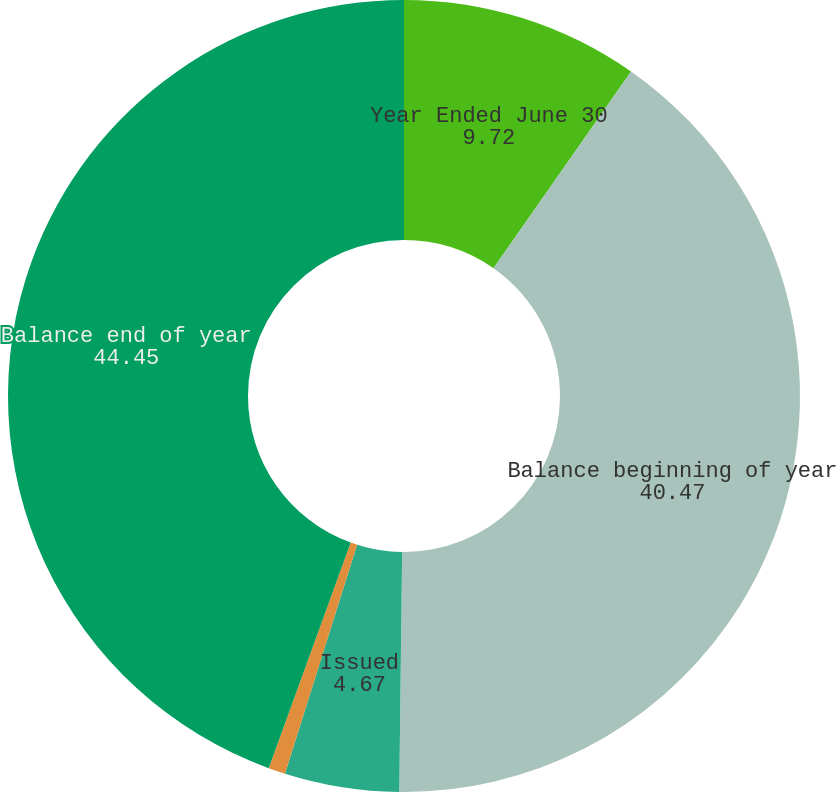Convert chart. <chart><loc_0><loc_0><loc_500><loc_500><pie_chart><fcel>Year Ended June 30<fcel>Balance beginning of year<fcel>Issued<fcel>Repurchased<fcel>Balance end of year<nl><fcel>9.72%<fcel>40.47%<fcel>4.67%<fcel>0.69%<fcel>44.45%<nl></chart> 